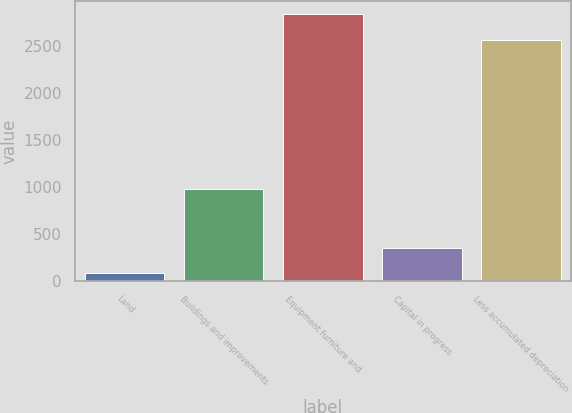Convert chart to OTSL. <chart><loc_0><loc_0><loc_500><loc_500><bar_chart><fcel>Land<fcel>Buildings and improvements<fcel>Equipment furniture and<fcel>Capital in progress<fcel>Less accumulated depreciation<nl><fcel>86<fcel>981<fcel>2842.7<fcel>356.7<fcel>2572<nl></chart> 